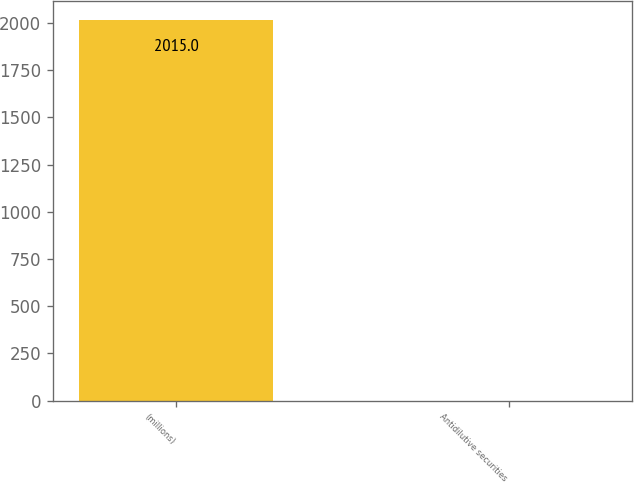Convert chart to OTSL. <chart><loc_0><loc_0><loc_500><loc_500><bar_chart><fcel>(millions)<fcel>Antidilutive securities<nl><fcel>2015<fcel>0.4<nl></chart> 